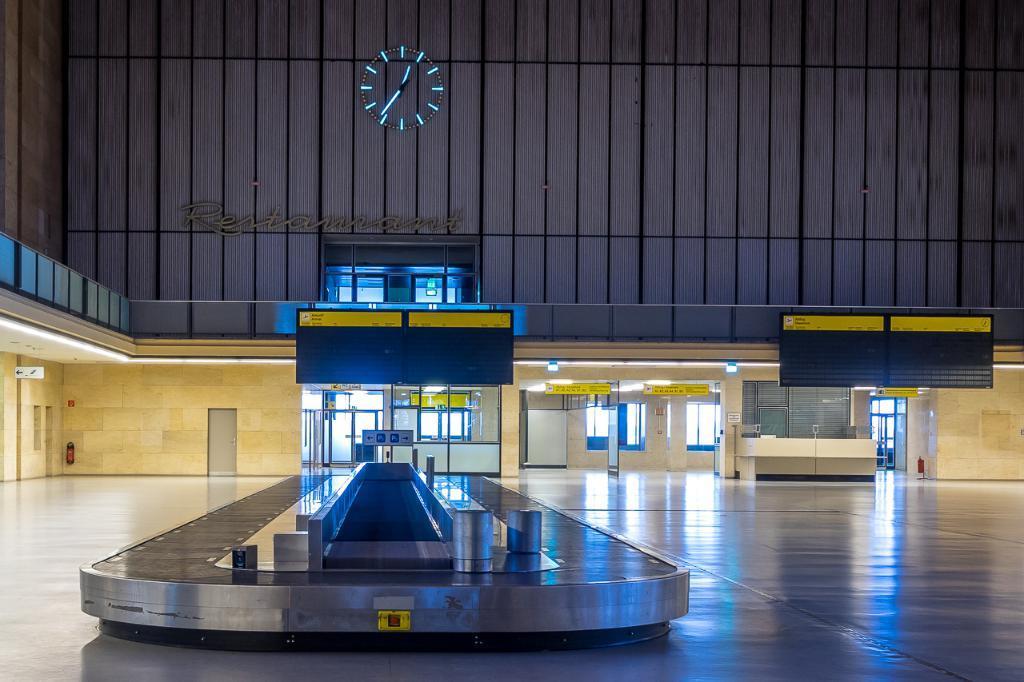In one or two sentences, can you explain what this image depicts? Here I can see an object on the floor. In the background there is a building. Here I can see few doors and windows to the wall. 